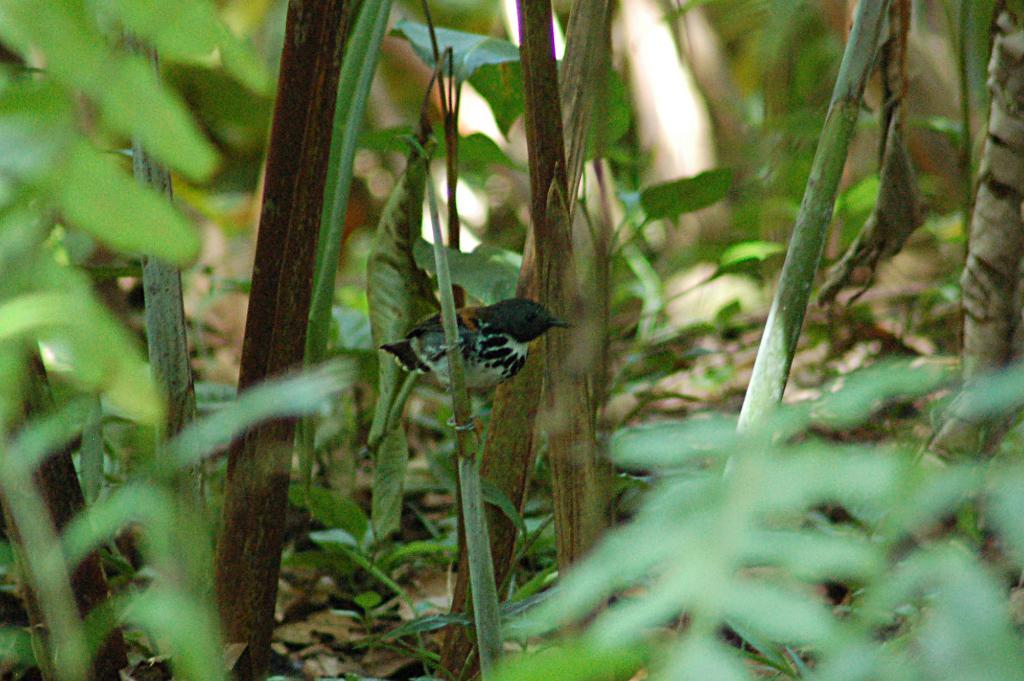What animal can be seen in the image? There is a bird in the image. Where is the bird located? The bird is sitting on a stem in the image. What type of vegetation is present in the image? There are leaves in the image, including some dry leaves. How would you describe the background of the image? The background of the image is slightly blurred. What shape is the goose in the image? There is no goose present in the image; it features a bird sitting on a stem. How does the bird interact with the square in the image? There is no square present in the image for the bird to interact with. 